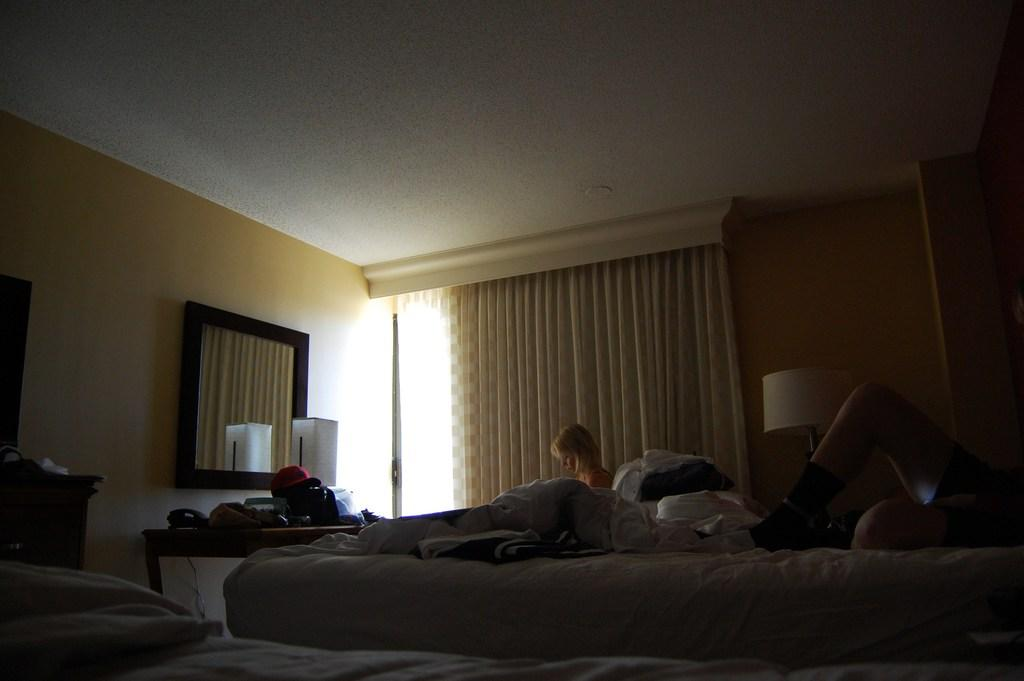What is the person in the image doing? The person is lying on a bed in the image. What object can be seen reflecting light in the image? There is a mirror in the image. What piece of furniture is present in the image? There is a table in the image. What type of poison is the person consuming in the image? There is no indication of any poison or consumption in the image; the person is simply lying on the bed. 